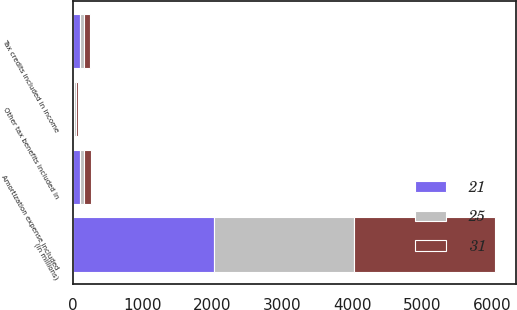Convert chart to OTSL. <chart><loc_0><loc_0><loc_500><loc_500><stacked_bar_chart><ecel><fcel>(in millions)<fcel>Tax credits included in income<fcel>Amortization expense included<fcel>Other tax benefits included in<nl><fcel>21<fcel>2018<fcel>101<fcel>110<fcel>25<nl><fcel>31<fcel>2017<fcel>83<fcel>94<fcel>31<nl><fcel>25<fcel>2016<fcel>59<fcel>59<fcel>21<nl></chart> 